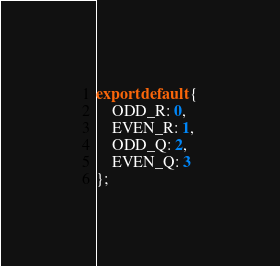Convert code to text. <code><loc_0><loc_0><loc_500><loc_500><_JavaScript_>export default {
    ODD_R: 0,
    EVEN_R: 1,
    ODD_Q: 2,
    EVEN_Q: 3
};</code> 